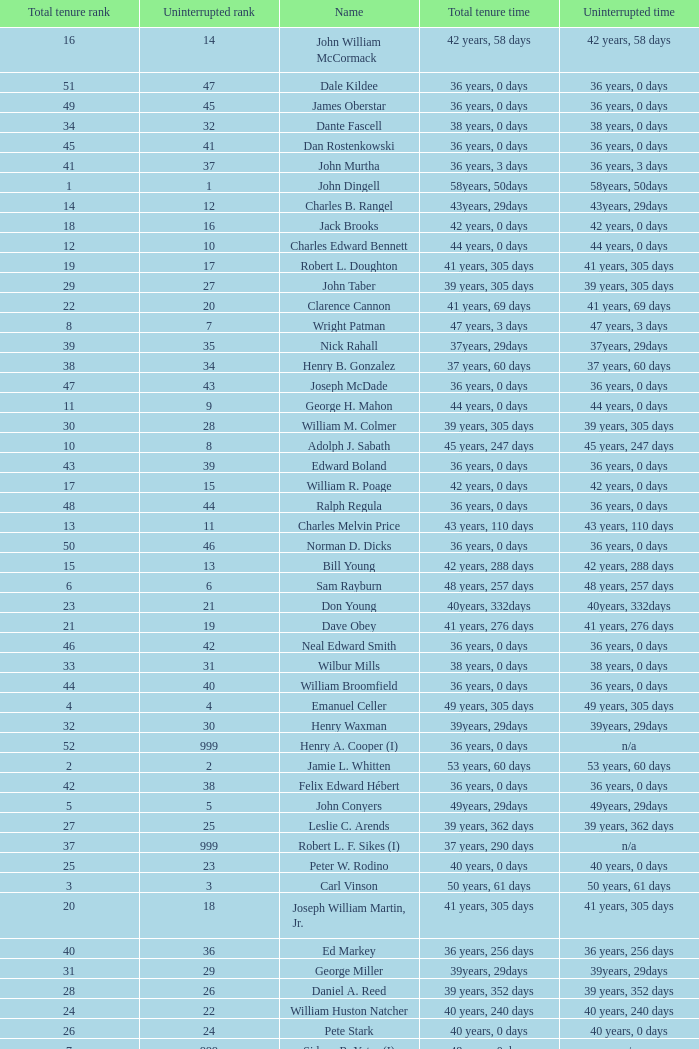Parse the table in full. {'header': ['Total tenure rank', 'Uninterrupted rank', 'Name', 'Total tenure time', 'Uninterrupted time'], 'rows': [['16', '14', 'John William McCormack', '42 years, 58 days', '42 years, 58 days'], ['51', '47', 'Dale Kildee', '36 years, 0 days', '36 years, 0 days'], ['49', '45', 'James Oberstar', '36 years, 0 days', '36 years, 0 days'], ['34', '32', 'Dante Fascell', '38 years, 0 days', '38 years, 0 days'], ['45', '41', 'Dan Rostenkowski', '36 years, 0 days', '36 years, 0 days'], ['41', '37', 'John Murtha', '36 years, 3 days', '36 years, 3 days'], ['1', '1', 'John Dingell', '58years, 50days', '58years, 50days'], ['14', '12', 'Charles B. Rangel', '43years, 29days', '43years, 29days'], ['18', '16', 'Jack Brooks', '42 years, 0 days', '42 years, 0 days'], ['12', '10', 'Charles Edward Bennett', '44 years, 0 days', '44 years, 0 days'], ['19', '17', 'Robert L. Doughton', '41 years, 305 days', '41 years, 305 days'], ['29', '27', 'John Taber', '39 years, 305 days', '39 years, 305 days'], ['22', '20', 'Clarence Cannon', '41 years, 69 days', '41 years, 69 days'], ['8', '7', 'Wright Patman', '47 years, 3 days', '47 years, 3 days'], ['39', '35', 'Nick Rahall', '37years, 29days', '37years, 29days'], ['38', '34', 'Henry B. Gonzalez', '37 years, 60 days', '37 years, 60 days'], ['47', '43', 'Joseph McDade', '36 years, 0 days', '36 years, 0 days'], ['11', '9', 'George H. Mahon', '44 years, 0 days', '44 years, 0 days'], ['30', '28', 'William M. Colmer', '39 years, 305 days', '39 years, 305 days'], ['10', '8', 'Adolph J. Sabath', '45 years, 247 days', '45 years, 247 days'], ['43', '39', 'Edward Boland', '36 years, 0 days', '36 years, 0 days'], ['17', '15', 'William R. Poage', '42 years, 0 days', '42 years, 0 days'], ['48', '44', 'Ralph Regula', '36 years, 0 days', '36 years, 0 days'], ['13', '11', 'Charles Melvin Price', '43 years, 110 days', '43 years, 110 days'], ['50', '46', 'Norman D. Dicks', '36 years, 0 days', '36 years, 0 days'], ['15', '13', 'Bill Young', '42 years, 288 days', '42 years, 288 days'], ['6', '6', 'Sam Rayburn', '48 years, 257 days', '48 years, 257 days'], ['23', '21', 'Don Young', '40years, 332days', '40years, 332days'], ['21', '19', 'Dave Obey', '41 years, 276 days', '41 years, 276 days'], ['46', '42', 'Neal Edward Smith', '36 years, 0 days', '36 years, 0 days'], ['33', '31', 'Wilbur Mills', '38 years, 0 days', '38 years, 0 days'], ['44', '40', 'William Broomfield', '36 years, 0 days', '36 years, 0 days'], ['4', '4', 'Emanuel Celler', '49 years, 305 days', '49 years, 305 days'], ['32', '30', 'Henry Waxman', '39years, 29days', '39years, 29days'], ['52', '999', 'Henry A. Cooper (I)', '36 years, 0 days', 'n/a'], ['2', '2', 'Jamie L. Whitten', '53 years, 60 days', '53 years, 60 days'], ['42', '38', 'Felix Edward Hébert', '36 years, 0 days', '36 years, 0 days'], ['5', '5', 'John Conyers', '49years, 29days', '49years, 29days'], ['27', '25', 'Leslie C. Arends', '39 years, 362 days', '39 years, 362 days'], ['37', '999', 'Robert L. F. Sikes (I)', '37 years, 290 days', 'n/a'], ['25', '23', 'Peter W. Rodino', '40 years, 0 days', '40 years, 0 days'], ['3', '3', 'Carl Vinson', '50 years, 61 days', '50 years, 61 days'], ['20', '18', 'Joseph William Martin, Jr.', '41 years, 305 days', '41 years, 305 days'], ['40', '36', 'Ed Markey', '36 years, 256 days', '36 years, 256 days'], ['31', '29', 'George Miller', '39years, 29days', '39years, 29days'], ['28', '26', 'Daniel A. Reed', '39 years, 352 days', '39 years, 352 days'], ['24', '22', 'William Huston Natcher', '40 years, 240 days', '40 years, 240 days'], ['26', '24', 'Pete Stark', '40 years, 0 days', '40 years, 0 days'], ['7', '999', 'Sidney R. Yates (I)', '48 years, 0 days', 'n/a'], ['9', '999', 'Joseph Gurney Cannon (I)', '46 years, 0 days', 'n/a'], ['36', '999', 'Robert Crosser (I)', '37 years, 305 days', 'n/a'], ['35', '33', 'Robert H. Michel', '38 years, 0 days', '38 years, 0 days']]} Who has a total tenure time and uninterrupted time of 36 years, 0 days, as well as a total tenure rank of 49? James Oberstar. 